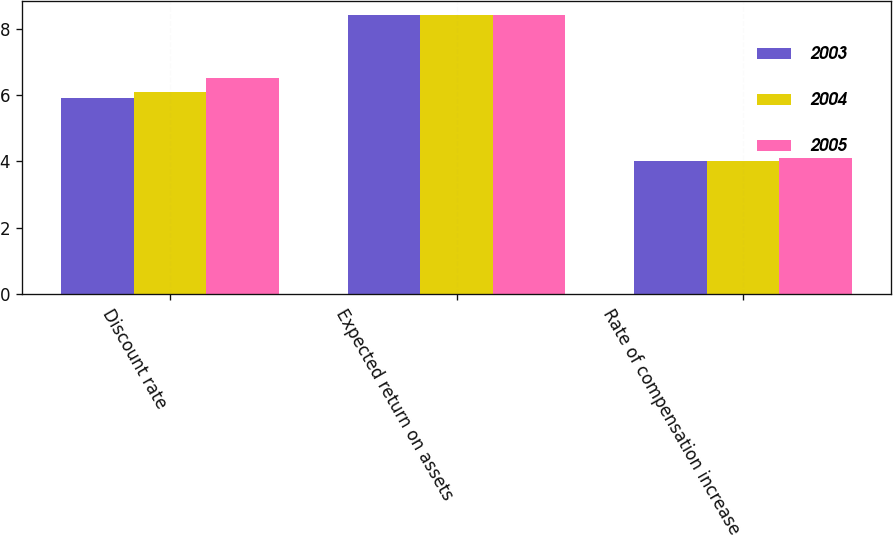<chart> <loc_0><loc_0><loc_500><loc_500><stacked_bar_chart><ecel><fcel>Discount rate<fcel>Expected return on assets<fcel>Rate of compensation increase<nl><fcel>2003<fcel>5.9<fcel>8.4<fcel>4<nl><fcel>2004<fcel>6.1<fcel>8.4<fcel>4<nl><fcel>2005<fcel>6.5<fcel>8.4<fcel>4.1<nl></chart> 